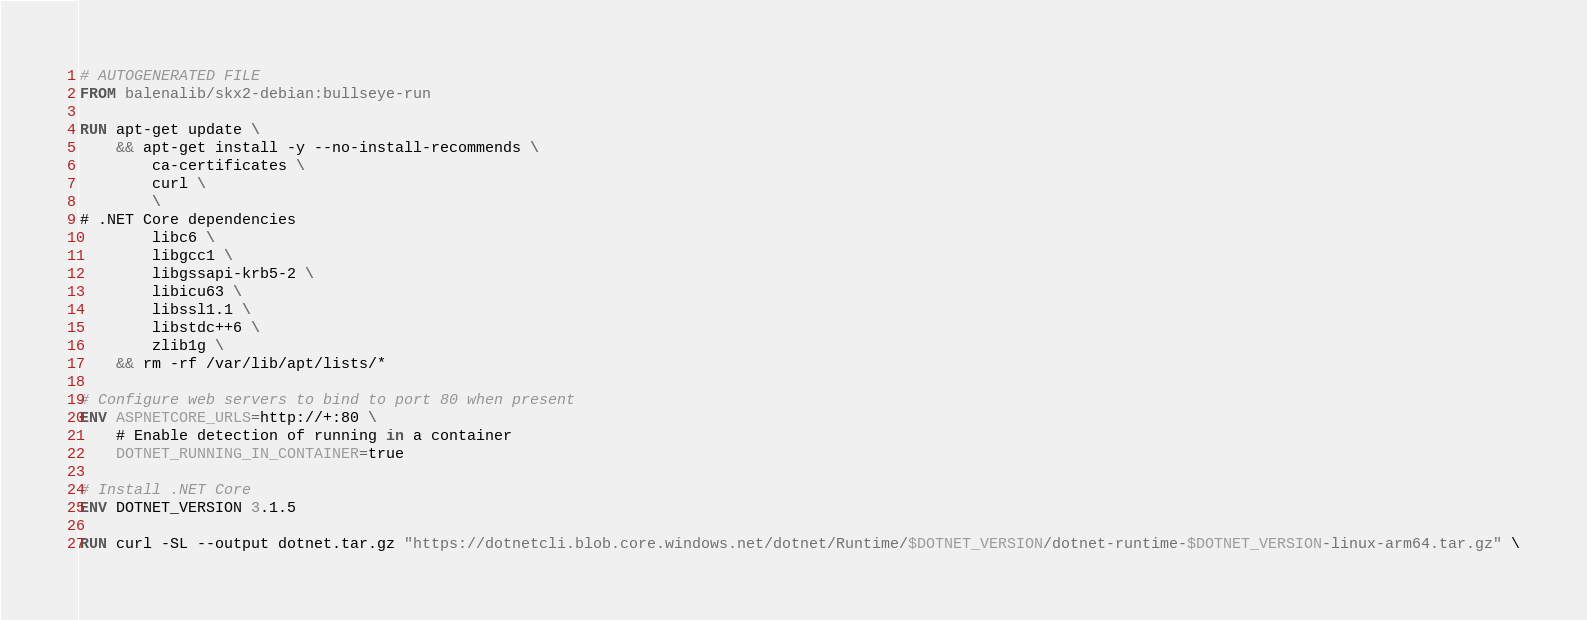Convert code to text. <code><loc_0><loc_0><loc_500><loc_500><_Dockerfile_># AUTOGENERATED FILE
FROM balenalib/skx2-debian:bullseye-run

RUN apt-get update \
    && apt-get install -y --no-install-recommends \
        ca-certificates \
        curl \
        \
# .NET Core dependencies
        libc6 \
        libgcc1 \
        libgssapi-krb5-2 \
        libicu63 \
        libssl1.1 \
        libstdc++6 \
        zlib1g \
    && rm -rf /var/lib/apt/lists/*

# Configure web servers to bind to port 80 when present
ENV ASPNETCORE_URLS=http://+:80 \
    # Enable detection of running in a container
    DOTNET_RUNNING_IN_CONTAINER=true

# Install .NET Core
ENV DOTNET_VERSION 3.1.5

RUN curl -SL --output dotnet.tar.gz "https://dotnetcli.blob.core.windows.net/dotnet/Runtime/$DOTNET_VERSION/dotnet-runtime-$DOTNET_VERSION-linux-arm64.tar.gz" \</code> 